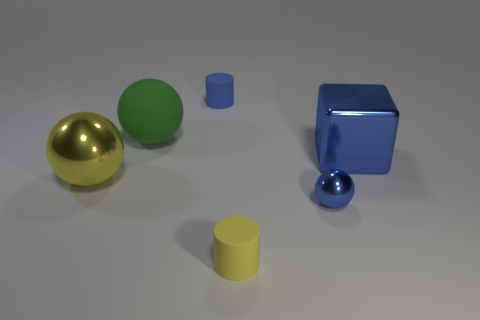Add 2 tiny purple matte cylinders. How many objects exist? 8 Subtract all cylinders. How many objects are left? 4 Add 4 large yellow things. How many large yellow things exist? 5 Subtract 0 brown balls. How many objects are left? 6 Subtract all big things. Subtract all yellow metal spheres. How many objects are left? 2 Add 2 blue balls. How many blue balls are left? 3 